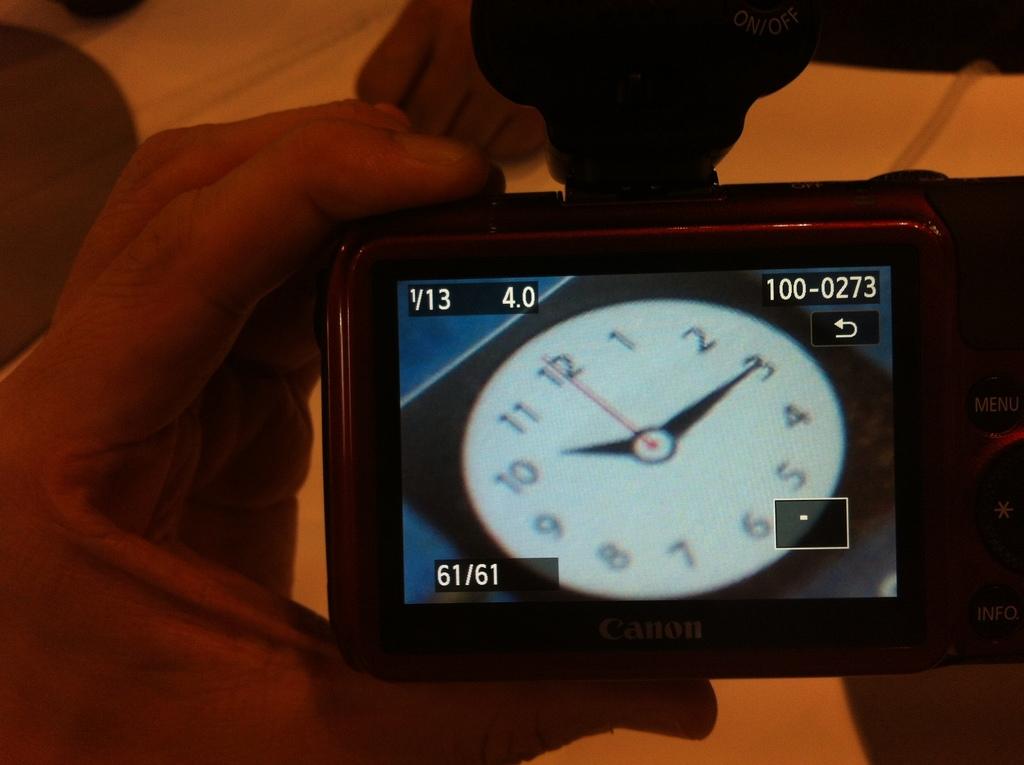What time is the clock?
Keep it short and to the point. 10:15. What kind of camera is displaying the clock?
Ensure brevity in your answer.  Canon. 